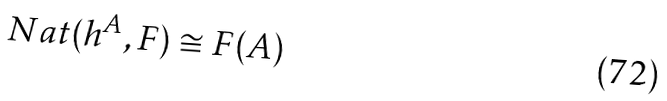<formula> <loc_0><loc_0><loc_500><loc_500>N a t ( h ^ { A } , F ) \cong F ( A )</formula> 